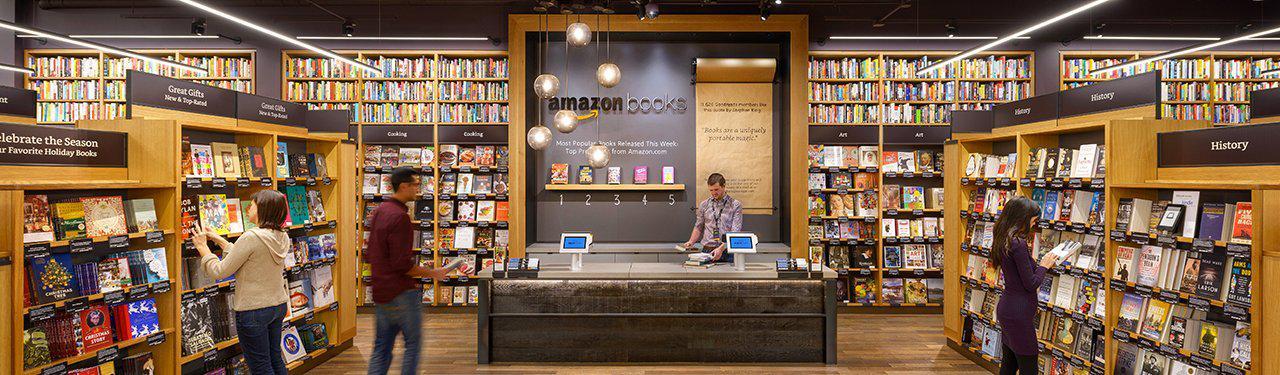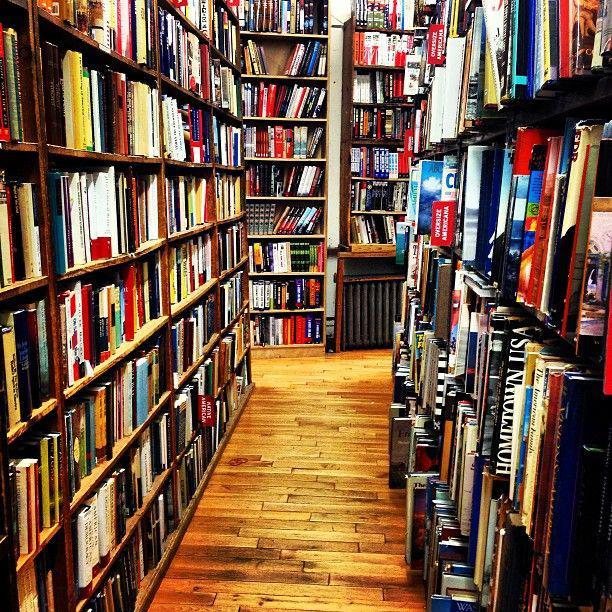The first image is the image on the left, the second image is the image on the right. Analyze the images presented: Is the assertion "There are at most 2 red chairs available for sitting." valid? Answer yes or no. No. The first image is the image on the left, the second image is the image on the right. Assess this claim about the two images: "There are multiple people in a bookstore in the left image.". Correct or not? Answer yes or no. Yes. 